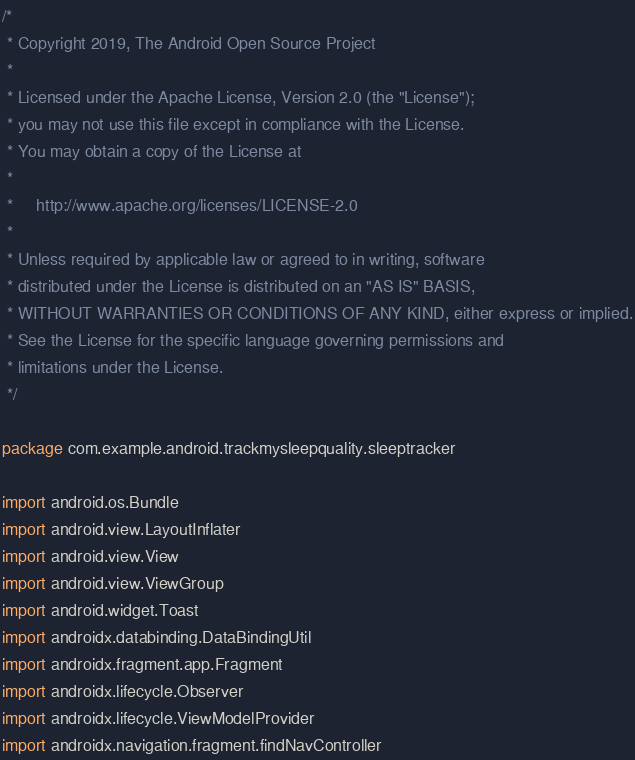Convert code to text. <code><loc_0><loc_0><loc_500><loc_500><_Kotlin_>/*
 * Copyright 2019, The Android Open Source Project
 *
 * Licensed under the Apache License, Version 2.0 (the "License");
 * you may not use this file except in compliance with the License.
 * You may obtain a copy of the License at
 *
 *     http://www.apache.org/licenses/LICENSE-2.0
 *
 * Unless required by applicable law or agreed to in writing, software
 * distributed under the License is distributed on an "AS IS" BASIS,
 * WITHOUT WARRANTIES OR CONDITIONS OF ANY KIND, either express or implied.
 * See the License for the specific language governing permissions and
 * limitations under the License.
 */

package com.example.android.trackmysleepquality.sleeptracker

import android.os.Bundle
import android.view.LayoutInflater
import android.view.View
import android.view.ViewGroup
import android.widget.Toast
import androidx.databinding.DataBindingUtil
import androidx.fragment.app.Fragment
import androidx.lifecycle.Observer
import androidx.lifecycle.ViewModelProvider
import androidx.navigation.fragment.findNavController</code> 